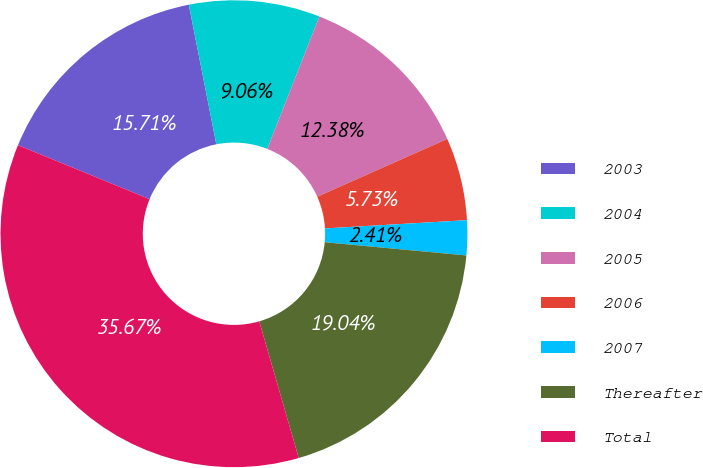Convert chart. <chart><loc_0><loc_0><loc_500><loc_500><pie_chart><fcel>2003<fcel>2004<fcel>2005<fcel>2006<fcel>2007<fcel>Thereafter<fcel>Total<nl><fcel>15.71%<fcel>9.06%<fcel>12.38%<fcel>5.73%<fcel>2.41%<fcel>19.04%<fcel>35.67%<nl></chart> 